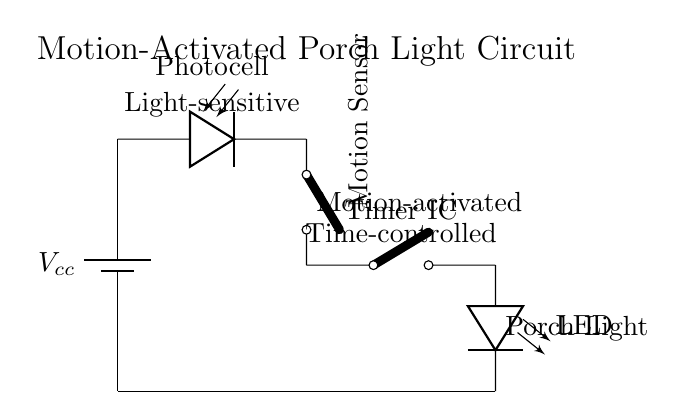What is the primary purpose of the photocell? The photocell is used to detect light levels; it only allows the circuit to activate under low-light conditions, ensuring the porch light operates at night.
Answer: Detect light levels What component controls the timing of the porch light activation? The Timer IC is responsible for controlling how long the light remains on after being activated by the motion sensor, providing the desired timeout period for the light.
Answer: Timer IC How many main components are in this circuit? The circuit consists of four main components: a battery, a photocell, a motion sensor, and a Timer IC that power and control the porch light.
Answer: Four In what condition does the motion sensor activate the circuit? The motion sensor activates when it detects movement, signaling the circuit to turn on the porch light if the conditions from the photocell are met (low light).
Answer: Detects movement What does the LED represent in this circuit? The LED symbolizes the porch light that illuminates when the photocell and motion sensor permit activation, serving as a visual signal that the circuit is operational.
Answer: Porch light 